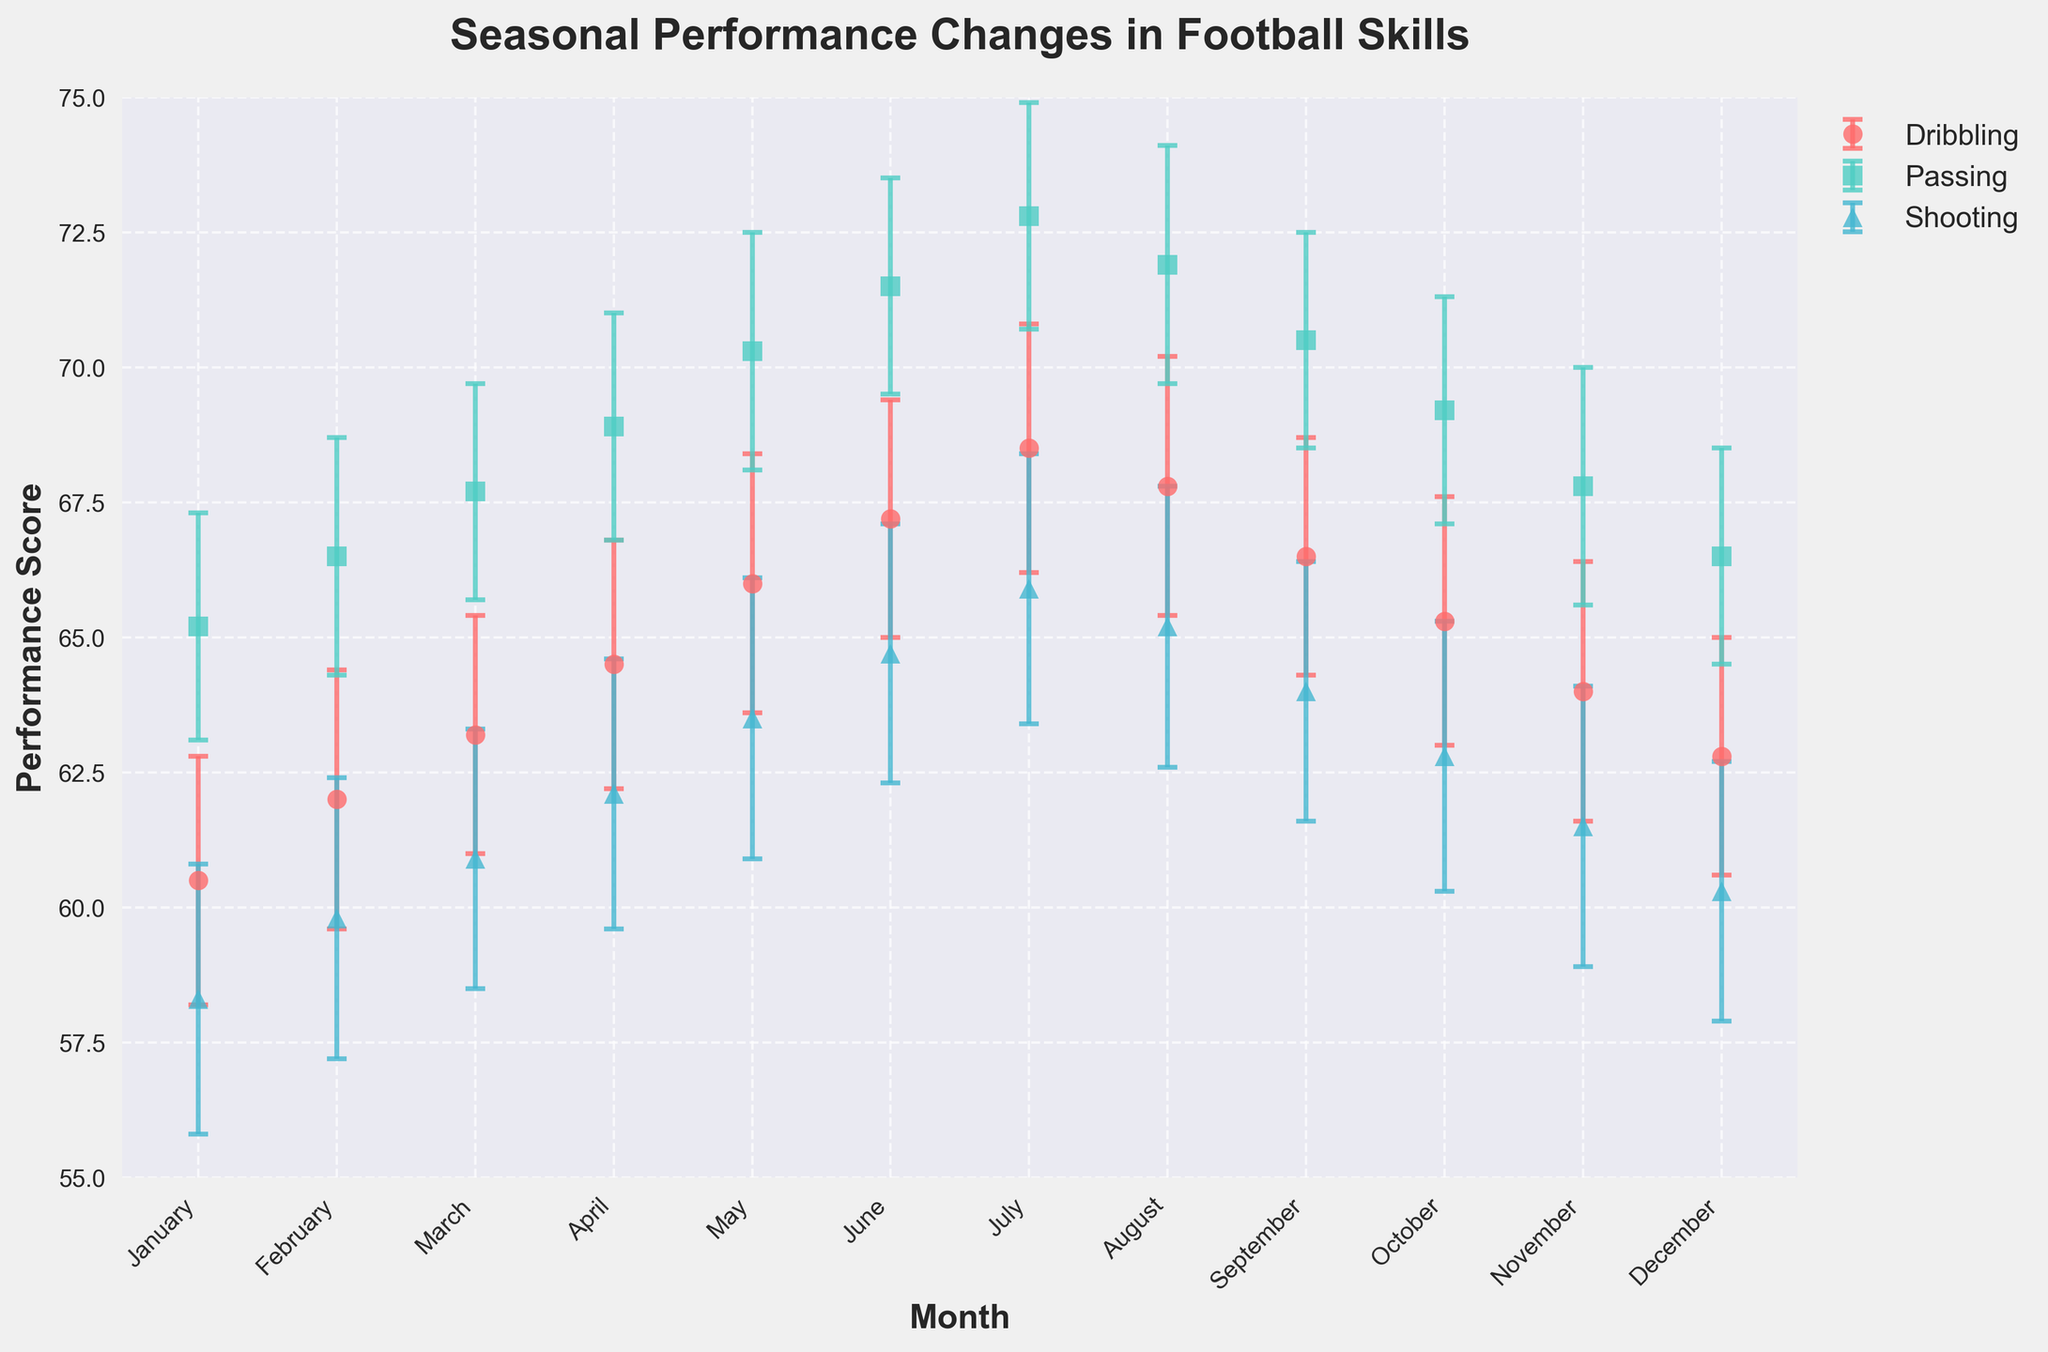What is the title of the plot? The title is found at the top of the plot and summarizes the visual content. The specific title in the plot is "Seasonal Performance Changes in Football Skills".
Answer: Seasonal Performance Changes in Football Skills Which month shows the highest average dribbling performance? To find this, look at the dribbling data points across all months and identify the highest value. The highest average dribbling performance is observed in July with a value of 68.5.
Answer: July Compare the average passing performance in May and November. Which month has a higher value? Check the average passing values for May and November. The average passing performance in May is 70.3, whereas in November it is 67.8. Hence, May has the higher value.
Answer: May How does the error bar for shooting in June compare to that in September? The error bars represent the standard errors. In June, the error for shooting is 2.4, and in September it is also 2.4. Since both have the same standard error, they are equal.
Answer: Equal What are the units used for the performance scores on the y-axis of the plot? The y-axis represents the performance scores, but the specific unit is not explicitly labeled. In this context, the unit is most likely a performance rating or score, though it is not defined in the plot.
Answer: Performance score Which skill shows the smallest increase in average performance from January to July? Calculate the difference in average performance for each skill between January and July: 
Dribbling increases from 60.5 to 68.5 (8.0), Passing from 65.2 to 72.8 (7.6), and Shooting from 58.3 to 65.9 (7.6). Both Passing and Shooting show the smallest increase of 7.6.
Answer: Passing and Shooting In which month is the average shooting performance the lowest? Look at the average shooting values across all months. The lowest average shooting performance is in January with a value of 58.3.
Answer: January What is the average passing score in the first quarter of the year? The first quarter includes January, February, and March. The average passing scores are 65.2, 66.5, and 67.7, respectively. The average for these three values is (65.2 + 66.5 + 67.7) / 3 = 66.47.
Answer: 66.47 During which month does dribbling show an average performance score closest to 65? Identify the dribbling average values for each month and determine which is nearest to 65. In October, the dribbling average is 65.3, which is the closest to 65.
Answer: October 